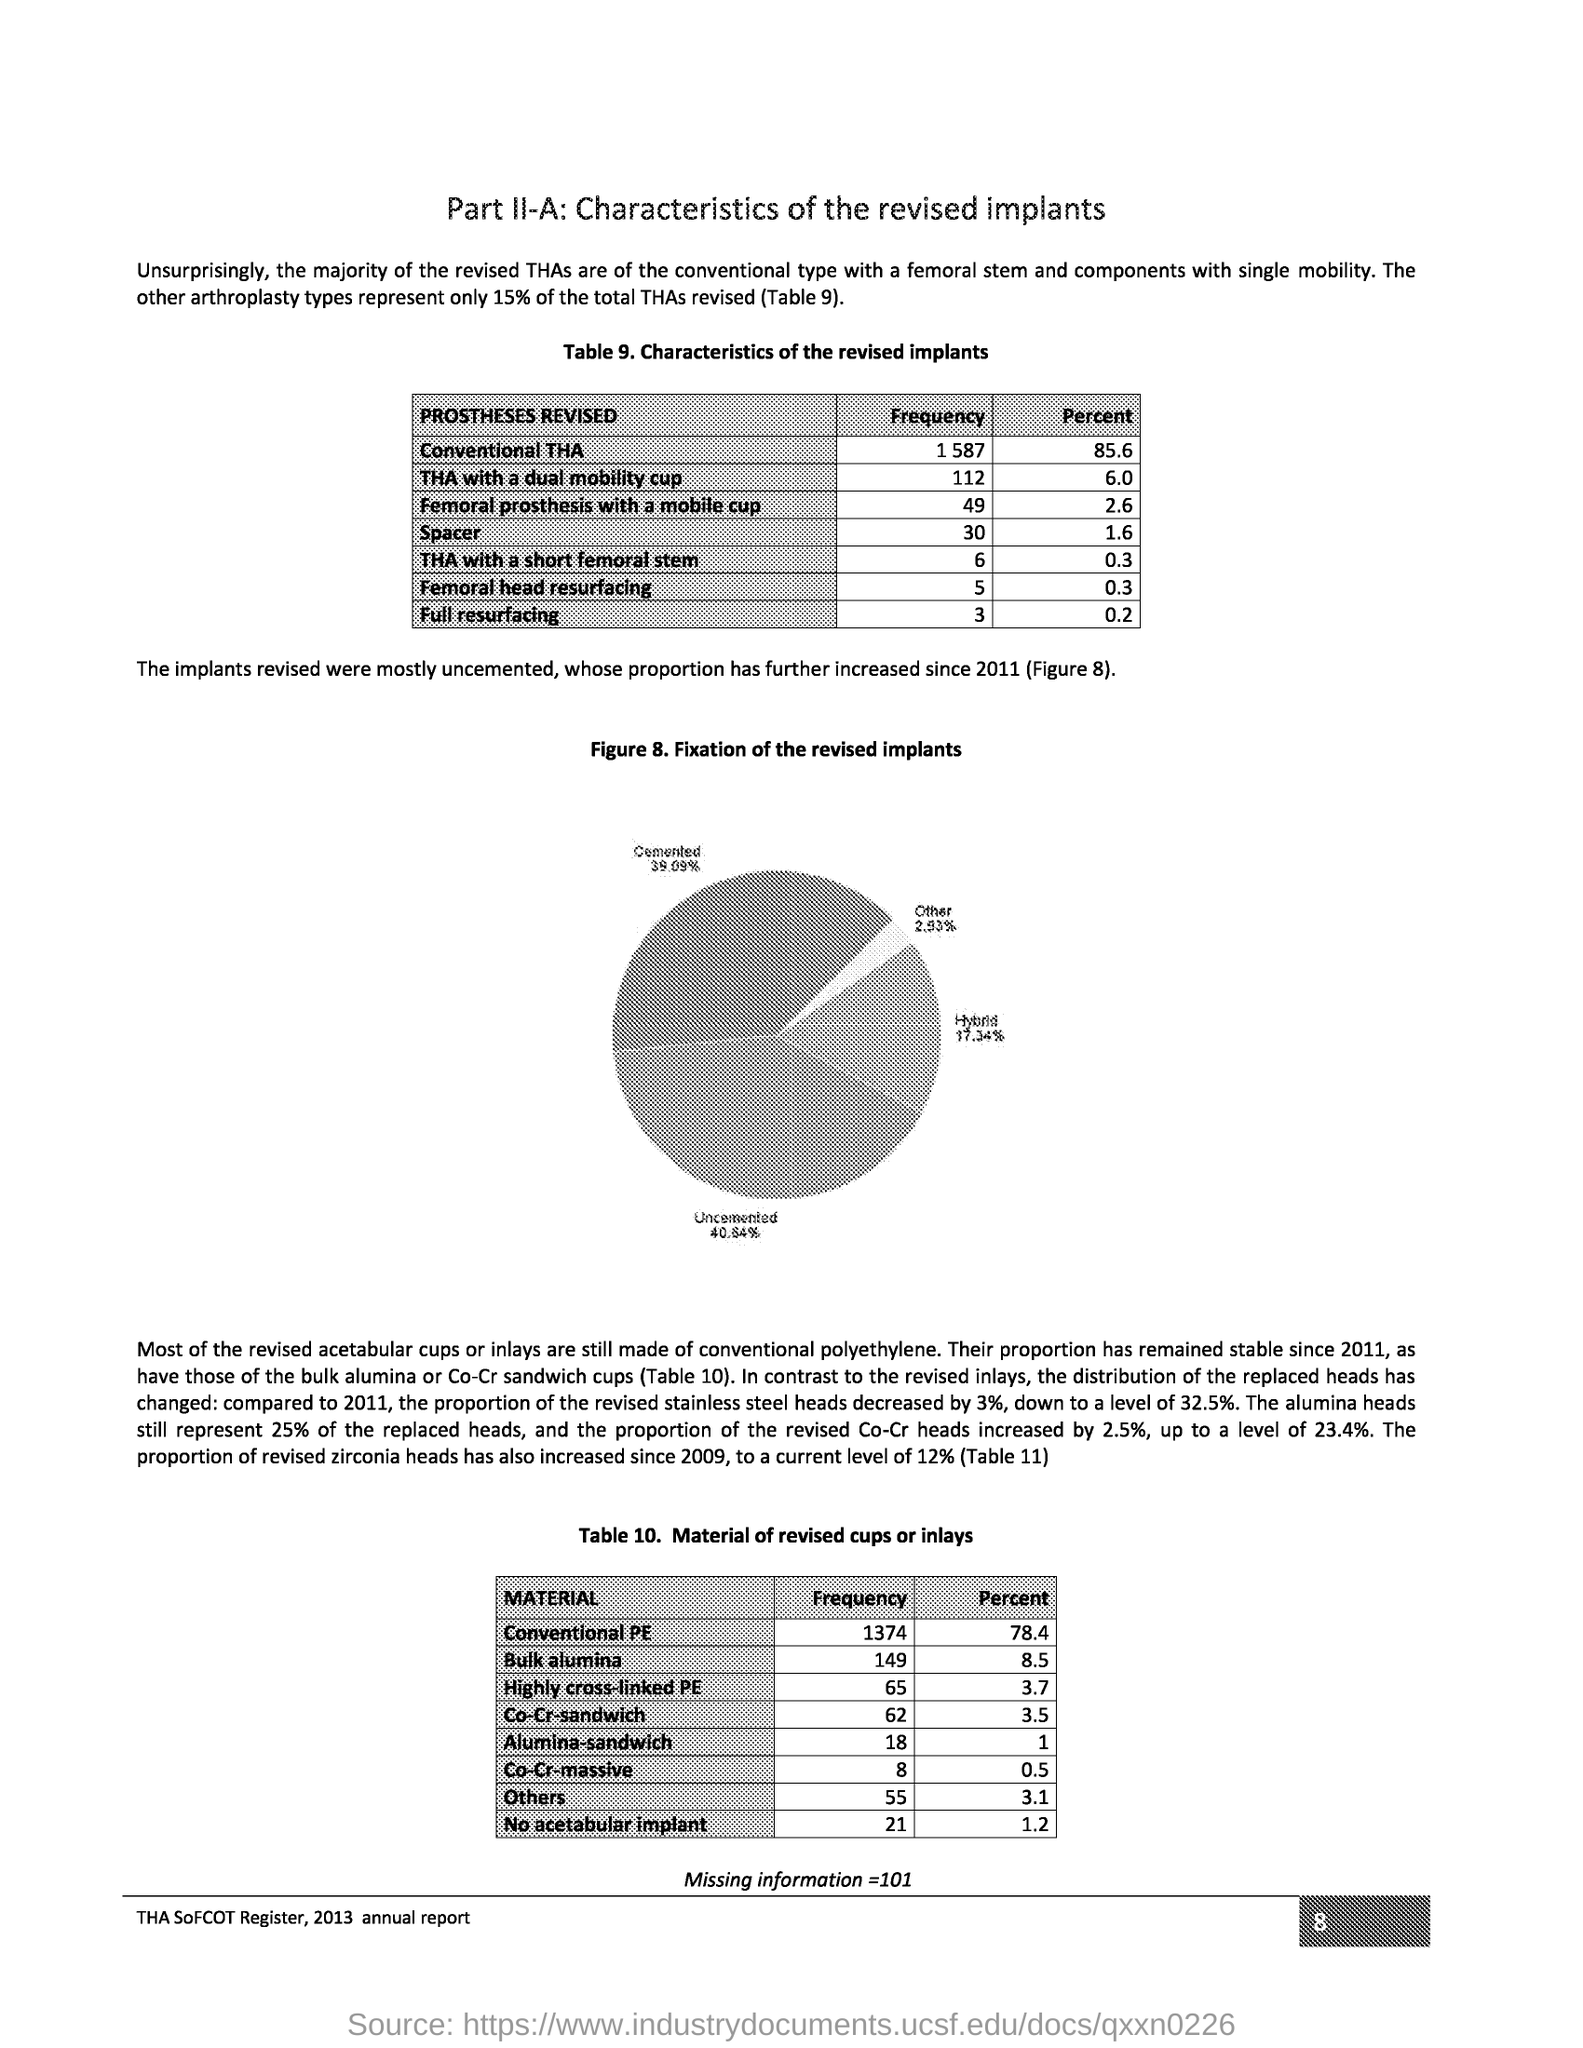Indicate a few pertinent items in this graphic. The frequency of THA with a short femoral stem is 6. The heading of table 10 is 'Material of revised cups or inlays'. The figure 8 title refers to the fixation of revised implants. The document title is "What is the document title? Part II-A: Characteristics of the revised implants."  The page is taken from the THA SoFCOT Register 2013 annual report. 